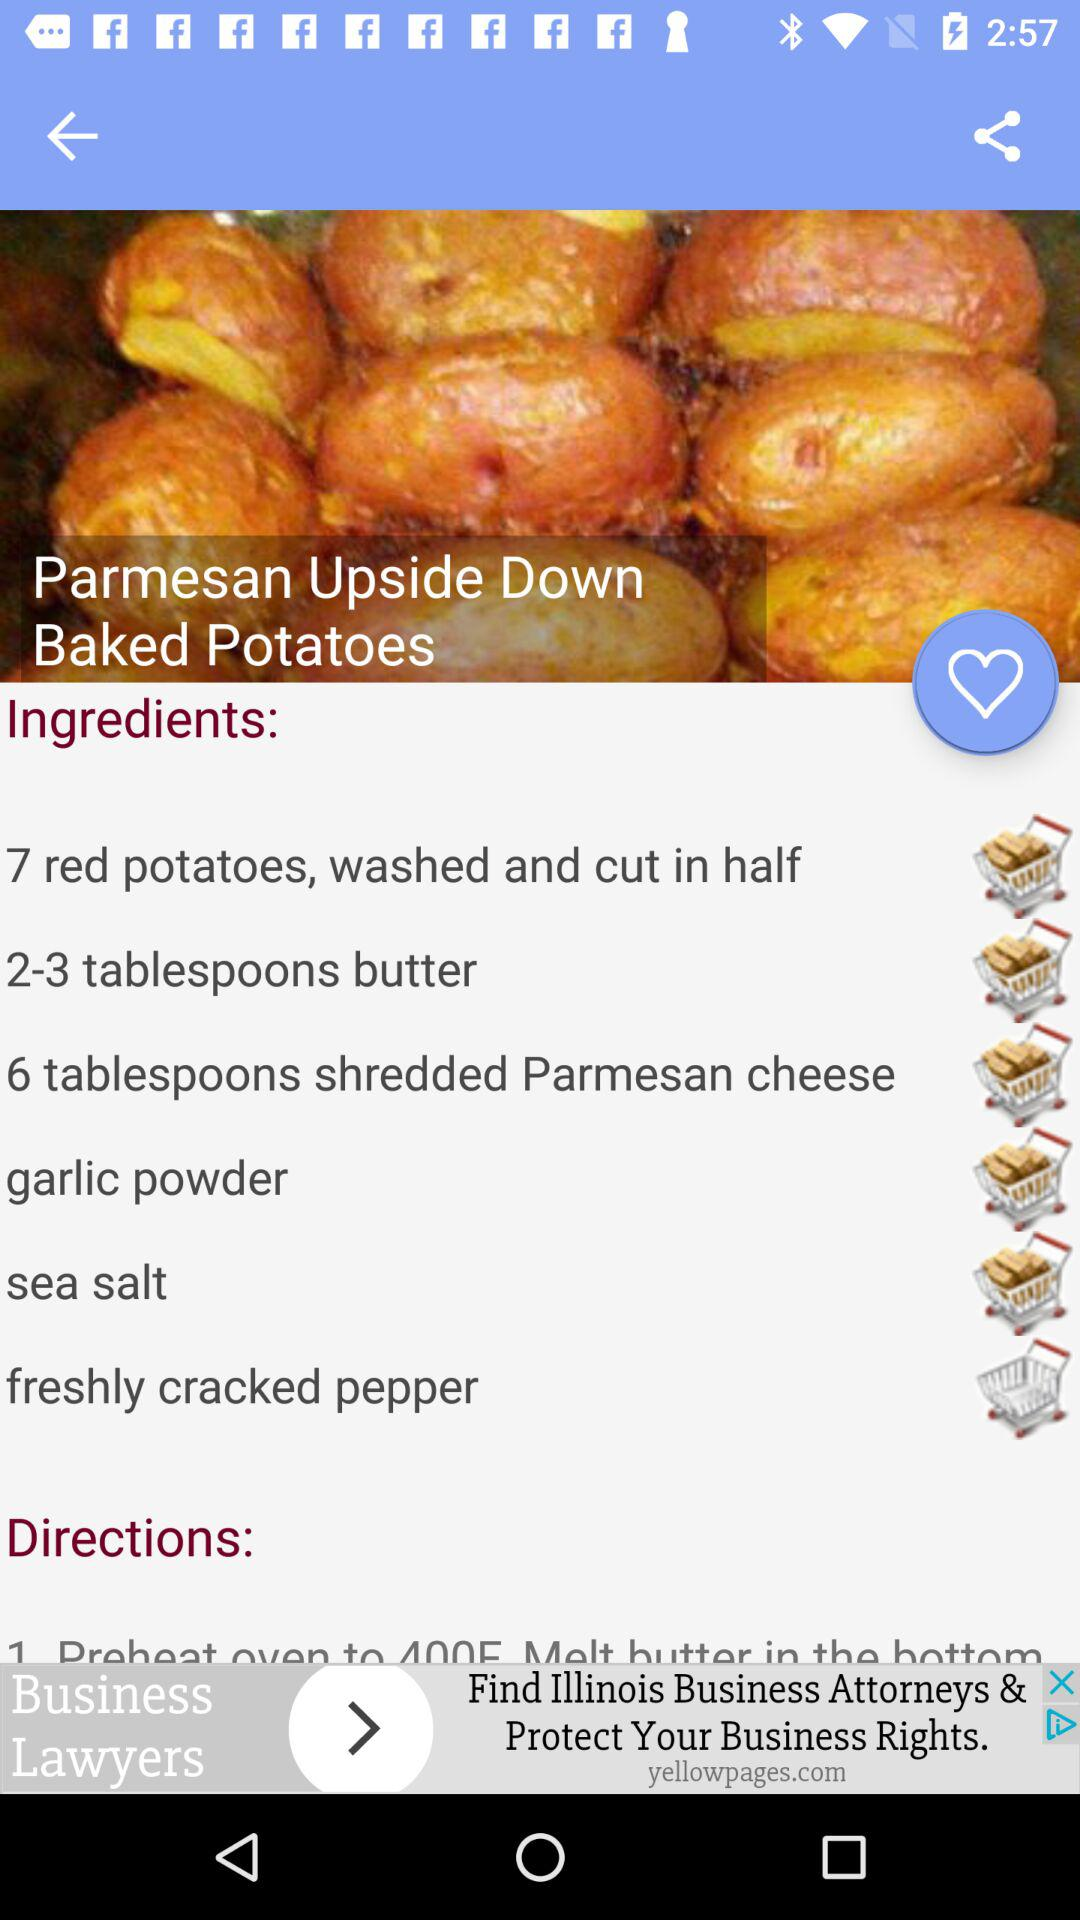What is the required number of tablespoons of "shredded Parmesan cheese"? The required number of tablespoons is 6. 